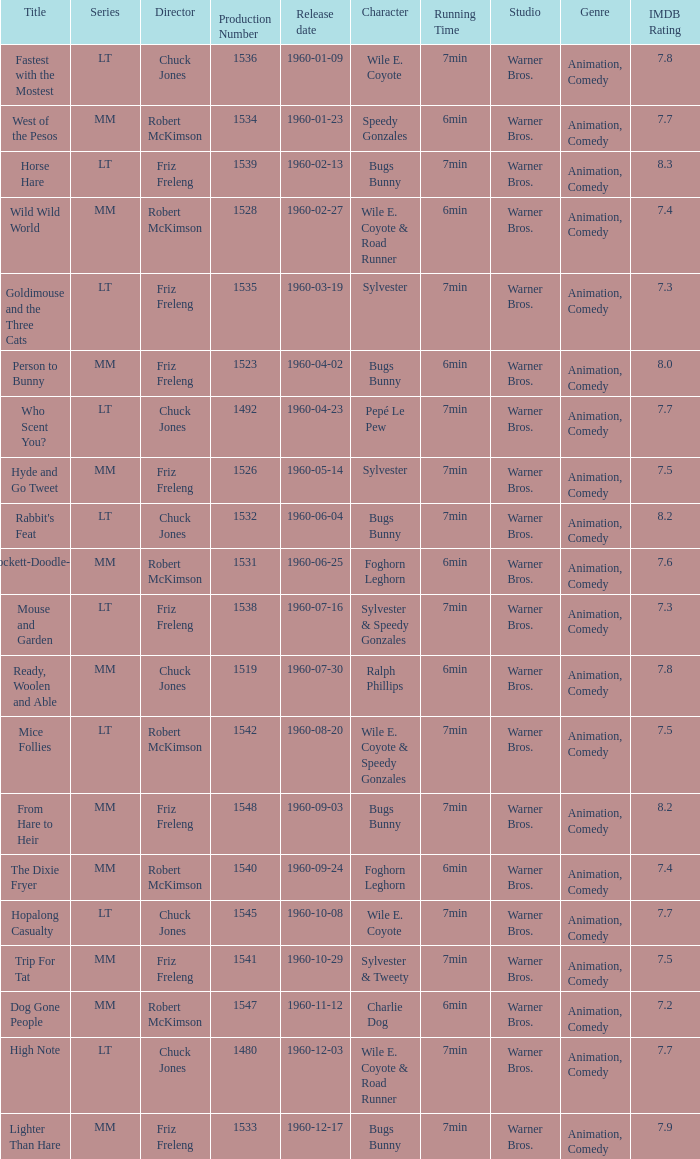What is the production number of From Hare to Heir? 1548.0. 